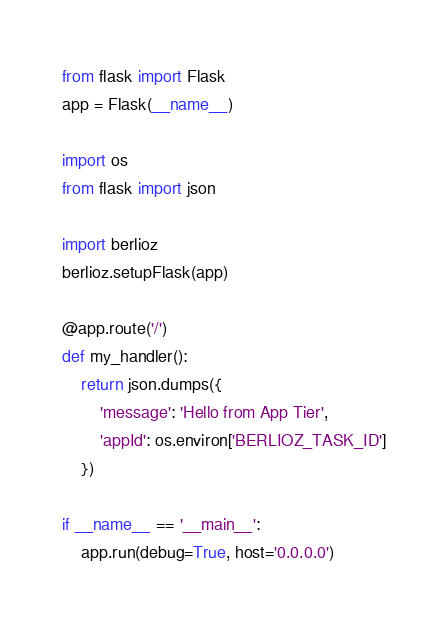<code> <loc_0><loc_0><loc_500><loc_500><_Python_>from flask import Flask
app = Flask(__name__)

import os
from flask import json

import berlioz
berlioz.setupFlask(app)

@app.route('/')
def my_handler():
    return json.dumps({
        'message': 'Hello from App Tier',
        'appId': os.environ['BERLIOZ_TASK_ID']
    })

if __name__ == '__main__':
    app.run(debug=True, host='0.0.0.0')</code> 